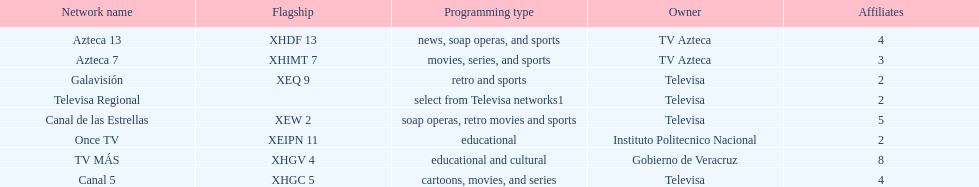Tell me the number of stations tv azteca owns. 2. 